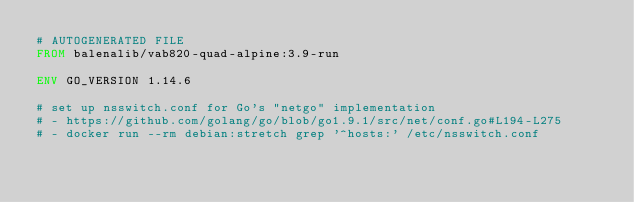Convert code to text. <code><loc_0><loc_0><loc_500><loc_500><_Dockerfile_># AUTOGENERATED FILE
FROM balenalib/vab820-quad-alpine:3.9-run

ENV GO_VERSION 1.14.6

# set up nsswitch.conf for Go's "netgo" implementation
# - https://github.com/golang/go/blob/go1.9.1/src/net/conf.go#L194-L275
# - docker run --rm debian:stretch grep '^hosts:' /etc/nsswitch.conf</code> 